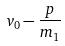<formula> <loc_0><loc_0><loc_500><loc_500>v _ { 0 } - \frac { p } { m _ { 1 } }</formula> 